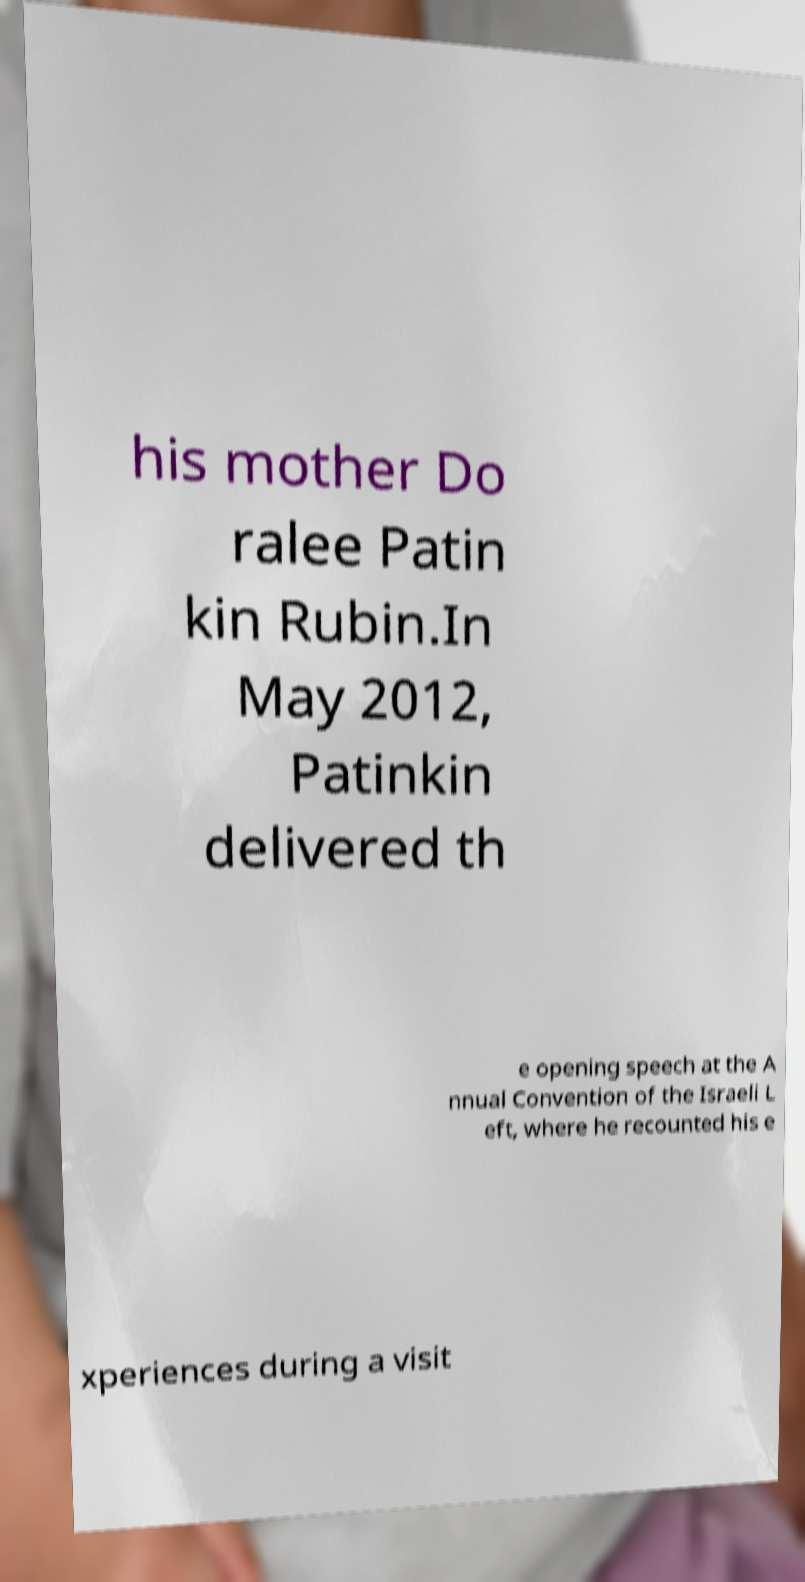Could you extract and type out the text from this image? his mother Do ralee Patin kin Rubin.In May 2012, Patinkin delivered th e opening speech at the A nnual Convention of the Israeli L eft, where he recounted his e xperiences during a visit 